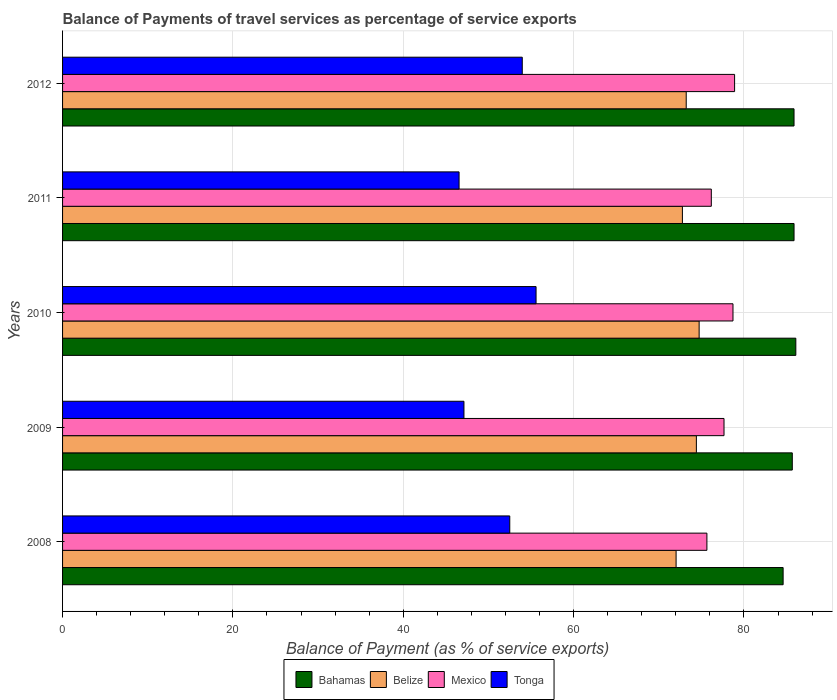Are the number of bars on each tick of the Y-axis equal?
Make the answer very short. Yes. How many bars are there on the 5th tick from the bottom?
Give a very brief answer. 4. In how many cases, is the number of bars for a given year not equal to the number of legend labels?
Provide a short and direct response. 0. What is the balance of payments of travel services in Tonga in 2012?
Keep it short and to the point. 53.97. Across all years, what is the maximum balance of payments of travel services in Tonga?
Provide a succinct answer. 55.59. Across all years, what is the minimum balance of payments of travel services in Tonga?
Keep it short and to the point. 46.55. In which year was the balance of payments of travel services in Bahamas minimum?
Offer a very short reply. 2008. What is the total balance of payments of travel services in Belize in the graph?
Offer a very short reply. 367.19. What is the difference between the balance of payments of travel services in Bahamas in 2008 and that in 2010?
Your answer should be compact. -1.49. What is the difference between the balance of payments of travel services in Bahamas in 2009 and the balance of payments of travel services in Mexico in 2012?
Make the answer very short. 6.77. What is the average balance of payments of travel services in Belize per year?
Give a very brief answer. 73.44. In the year 2010, what is the difference between the balance of payments of travel services in Tonga and balance of payments of travel services in Mexico?
Your answer should be very brief. -23.12. In how many years, is the balance of payments of travel services in Bahamas greater than 48 %?
Your answer should be compact. 5. What is the ratio of the balance of payments of travel services in Bahamas in 2010 to that in 2012?
Provide a short and direct response. 1. Is the difference between the balance of payments of travel services in Tonga in 2008 and 2012 greater than the difference between the balance of payments of travel services in Mexico in 2008 and 2012?
Ensure brevity in your answer.  Yes. What is the difference between the highest and the second highest balance of payments of travel services in Tonga?
Ensure brevity in your answer.  1.62. What is the difference between the highest and the lowest balance of payments of travel services in Bahamas?
Your answer should be compact. 1.49. In how many years, is the balance of payments of travel services in Belize greater than the average balance of payments of travel services in Belize taken over all years?
Offer a terse response. 2. What does the 4th bar from the top in 2010 represents?
Offer a very short reply. Bahamas. What does the 1st bar from the bottom in 2008 represents?
Keep it short and to the point. Bahamas. How many years are there in the graph?
Give a very brief answer. 5. What is the difference between two consecutive major ticks on the X-axis?
Your response must be concise. 20. Does the graph contain grids?
Provide a succinct answer. Yes. Where does the legend appear in the graph?
Your response must be concise. Bottom center. What is the title of the graph?
Provide a short and direct response. Balance of Payments of travel services as percentage of service exports. What is the label or title of the X-axis?
Your answer should be compact. Balance of Payment (as % of service exports). What is the Balance of Payment (as % of service exports) of Bahamas in 2008?
Provide a short and direct response. 84.6. What is the Balance of Payment (as % of service exports) of Belize in 2008?
Offer a terse response. 72.03. What is the Balance of Payment (as % of service exports) in Mexico in 2008?
Make the answer very short. 75.65. What is the Balance of Payment (as % of service exports) in Tonga in 2008?
Give a very brief answer. 52.51. What is the Balance of Payment (as % of service exports) in Bahamas in 2009?
Provide a short and direct response. 85.68. What is the Balance of Payment (as % of service exports) in Belize in 2009?
Make the answer very short. 74.42. What is the Balance of Payment (as % of service exports) in Mexico in 2009?
Give a very brief answer. 77.66. What is the Balance of Payment (as % of service exports) of Tonga in 2009?
Offer a very short reply. 47.13. What is the Balance of Payment (as % of service exports) in Bahamas in 2010?
Your answer should be very brief. 86.09. What is the Balance of Payment (as % of service exports) of Belize in 2010?
Offer a very short reply. 74.74. What is the Balance of Payment (as % of service exports) in Mexico in 2010?
Your answer should be very brief. 78.71. What is the Balance of Payment (as % of service exports) in Tonga in 2010?
Provide a succinct answer. 55.59. What is the Balance of Payment (as % of service exports) of Bahamas in 2011?
Make the answer very short. 85.88. What is the Balance of Payment (as % of service exports) of Belize in 2011?
Provide a succinct answer. 72.78. What is the Balance of Payment (as % of service exports) in Mexico in 2011?
Make the answer very short. 76.17. What is the Balance of Payment (as % of service exports) in Tonga in 2011?
Your answer should be very brief. 46.55. What is the Balance of Payment (as % of service exports) in Bahamas in 2012?
Provide a succinct answer. 85.88. What is the Balance of Payment (as % of service exports) of Belize in 2012?
Provide a succinct answer. 73.22. What is the Balance of Payment (as % of service exports) of Mexico in 2012?
Your answer should be compact. 78.9. What is the Balance of Payment (as % of service exports) of Tonga in 2012?
Your response must be concise. 53.97. Across all years, what is the maximum Balance of Payment (as % of service exports) of Bahamas?
Your answer should be very brief. 86.09. Across all years, what is the maximum Balance of Payment (as % of service exports) of Belize?
Your answer should be very brief. 74.74. Across all years, what is the maximum Balance of Payment (as % of service exports) in Mexico?
Offer a very short reply. 78.9. Across all years, what is the maximum Balance of Payment (as % of service exports) in Tonga?
Your answer should be compact. 55.59. Across all years, what is the minimum Balance of Payment (as % of service exports) in Bahamas?
Give a very brief answer. 84.6. Across all years, what is the minimum Balance of Payment (as % of service exports) in Belize?
Your answer should be very brief. 72.03. Across all years, what is the minimum Balance of Payment (as % of service exports) in Mexico?
Keep it short and to the point. 75.65. Across all years, what is the minimum Balance of Payment (as % of service exports) of Tonga?
Make the answer very short. 46.55. What is the total Balance of Payment (as % of service exports) in Bahamas in the graph?
Ensure brevity in your answer.  428.14. What is the total Balance of Payment (as % of service exports) in Belize in the graph?
Ensure brevity in your answer.  367.19. What is the total Balance of Payment (as % of service exports) in Mexico in the graph?
Your answer should be compact. 387.1. What is the total Balance of Payment (as % of service exports) in Tonga in the graph?
Provide a short and direct response. 255.76. What is the difference between the Balance of Payment (as % of service exports) of Bahamas in 2008 and that in 2009?
Keep it short and to the point. -1.08. What is the difference between the Balance of Payment (as % of service exports) of Belize in 2008 and that in 2009?
Make the answer very short. -2.38. What is the difference between the Balance of Payment (as % of service exports) in Mexico in 2008 and that in 2009?
Offer a terse response. -2.01. What is the difference between the Balance of Payment (as % of service exports) in Tonga in 2008 and that in 2009?
Provide a short and direct response. 5.38. What is the difference between the Balance of Payment (as % of service exports) of Bahamas in 2008 and that in 2010?
Ensure brevity in your answer.  -1.49. What is the difference between the Balance of Payment (as % of service exports) in Belize in 2008 and that in 2010?
Offer a very short reply. -2.71. What is the difference between the Balance of Payment (as % of service exports) in Mexico in 2008 and that in 2010?
Your answer should be compact. -3.06. What is the difference between the Balance of Payment (as % of service exports) of Tonga in 2008 and that in 2010?
Offer a terse response. -3.09. What is the difference between the Balance of Payment (as % of service exports) in Bahamas in 2008 and that in 2011?
Make the answer very short. -1.28. What is the difference between the Balance of Payment (as % of service exports) in Belize in 2008 and that in 2011?
Provide a short and direct response. -0.74. What is the difference between the Balance of Payment (as % of service exports) in Mexico in 2008 and that in 2011?
Give a very brief answer. -0.52. What is the difference between the Balance of Payment (as % of service exports) in Tonga in 2008 and that in 2011?
Your response must be concise. 5.95. What is the difference between the Balance of Payment (as % of service exports) in Bahamas in 2008 and that in 2012?
Ensure brevity in your answer.  -1.28. What is the difference between the Balance of Payment (as % of service exports) in Belize in 2008 and that in 2012?
Your answer should be compact. -1.19. What is the difference between the Balance of Payment (as % of service exports) of Mexico in 2008 and that in 2012?
Your answer should be very brief. -3.25. What is the difference between the Balance of Payment (as % of service exports) of Tonga in 2008 and that in 2012?
Give a very brief answer. -1.47. What is the difference between the Balance of Payment (as % of service exports) of Bahamas in 2009 and that in 2010?
Your answer should be very brief. -0.42. What is the difference between the Balance of Payment (as % of service exports) of Belize in 2009 and that in 2010?
Provide a succinct answer. -0.32. What is the difference between the Balance of Payment (as % of service exports) in Mexico in 2009 and that in 2010?
Make the answer very short. -1.05. What is the difference between the Balance of Payment (as % of service exports) in Tonga in 2009 and that in 2010?
Give a very brief answer. -8.47. What is the difference between the Balance of Payment (as % of service exports) of Bahamas in 2009 and that in 2011?
Ensure brevity in your answer.  -0.21. What is the difference between the Balance of Payment (as % of service exports) of Belize in 2009 and that in 2011?
Your answer should be very brief. 1.64. What is the difference between the Balance of Payment (as % of service exports) in Mexico in 2009 and that in 2011?
Provide a succinct answer. 1.49. What is the difference between the Balance of Payment (as % of service exports) in Tonga in 2009 and that in 2011?
Give a very brief answer. 0.57. What is the difference between the Balance of Payment (as % of service exports) in Bahamas in 2009 and that in 2012?
Your answer should be very brief. -0.2. What is the difference between the Balance of Payment (as % of service exports) of Belize in 2009 and that in 2012?
Give a very brief answer. 1.19. What is the difference between the Balance of Payment (as % of service exports) of Mexico in 2009 and that in 2012?
Provide a succinct answer. -1.24. What is the difference between the Balance of Payment (as % of service exports) of Tonga in 2009 and that in 2012?
Your answer should be compact. -6.85. What is the difference between the Balance of Payment (as % of service exports) of Bahamas in 2010 and that in 2011?
Your answer should be compact. 0.21. What is the difference between the Balance of Payment (as % of service exports) of Belize in 2010 and that in 2011?
Your answer should be very brief. 1.96. What is the difference between the Balance of Payment (as % of service exports) of Mexico in 2010 and that in 2011?
Give a very brief answer. 2.54. What is the difference between the Balance of Payment (as % of service exports) of Tonga in 2010 and that in 2011?
Offer a terse response. 9.04. What is the difference between the Balance of Payment (as % of service exports) of Bahamas in 2010 and that in 2012?
Your response must be concise. 0.21. What is the difference between the Balance of Payment (as % of service exports) in Belize in 2010 and that in 2012?
Give a very brief answer. 1.52. What is the difference between the Balance of Payment (as % of service exports) of Mexico in 2010 and that in 2012?
Keep it short and to the point. -0.19. What is the difference between the Balance of Payment (as % of service exports) in Tonga in 2010 and that in 2012?
Provide a succinct answer. 1.62. What is the difference between the Balance of Payment (as % of service exports) of Bahamas in 2011 and that in 2012?
Offer a terse response. 0. What is the difference between the Balance of Payment (as % of service exports) in Belize in 2011 and that in 2012?
Make the answer very short. -0.45. What is the difference between the Balance of Payment (as % of service exports) in Mexico in 2011 and that in 2012?
Provide a succinct answer. -2.73. What is the difference between the Balance of Payment (as % of service exports) in Tonga in 2011 and that in 2012?
Provide a succinct answer. -7.42. What is the difference between the Balance of Payment (as % of service exports) of Bahamas in 2008 and the Balance of Payment (as % of service exports) of Belize in 2009?
Ensure brevity in your answer.  10.19. What is the difference between the Balance of Payment (as % of service exports) of Bahamas in 2008 and the Balance of Payment (as % of service exports) of Mexico in 2009?
Offer a very short reply. 6.94. What is the difference between the Balance of Payment (as % of service exports) of Bahamas in 2008 and the Balance of Payment (as % of service exports) of Tonga in 2009?
Give a very brief answer. 37.48. What is the difference between the Balance of Payment (as % of service exports) in Belize in 2008 and the Balance of Payment (as % of service exports) in Mexico in 2009?
Offer a terse response. -5.63. What is the difference between the Balance of Payment (as % of service exports) of Belize in 2008 and the Balance of Payment (as % of service exports) of Tonga in 2009?
Provide a succinct answer. 24.91. What is the difference between the Balance of Payment (as % of service exports) in Mexico in 2008 and the Balance of Payment (as % of service exports) in Tonga in 2009?
Keep it short and to the point. 28.53. What is the difference between the Balance of Payment (as % of service exports) in Bahamas in 2008 and the Balance of Payment (as % of service exports) in Belize in 2010?
Ensure brevity in your answer.  9.86. What is the difference between the Balance of Payment (as % of service exports) in Bahamas in 2008 and the Balance of Payment (as % of service exports) in Mexico in 2010?
Provide a succinct answer. 5.89. What is the difference between the Balance of Payment (as % of service exports) of Bahamas in 2008 and the Balance of Payment (as % of service exports) of Tonga in 2010?
Provide a succinct answer. 29.01. What is the difference between the Balance of Payment (as % of service exports) in Belize in 2008 and the Balance of Payment (as % of service exports) in Mexico in 2010?
Ensure brevity in your answer.  -6.68. What is the difference between the Balance of Payment (as % of service exports) in Belize in 2008 and the Balance of Payment (as % of service exports) in Tonga in 2010?
Keep it short and to the point. 16.44. What is the difference between the Balance of Payment (as % of service exports) of Mexico in 2008 and the Balance of Payment (as % of service exports) of Tonga in 2010?
Ensure brevity in your answer.  20.06. What is the difference between the Balance of Payment (as % of service exports) of Bahamas in 2008 and the Balance of Payment (as % of service exports) of Belize in 2011?
Your answer should be compact. 11.83. What is the difference between the Balance of Payment (as % of service exports) in Bahamas in 2008 and the Balance of Payment (as % of service exports) in Mexico in 2011?
Make the answer very short. 8.43. What is the difference between the Balance of Payment (as % of service exports) in Bahamas in 2008 and the Balance of Payment (as % of service exports) in Tonga in 2011?
Offer a terse response. 38.05. What is the difference between the Balance of Payment (as % of service exports) in Belize in 2008 and the Balance of Payment (as % of service exports) in Mexico in 2011?
Provide a short and direct response. -4.14. What is the difference between the Balance of Payment (as % of service exports) of Belize in 2008 and the Balance of Payment (as % of service exports) of Tonga in 2011?
Offer a terse response. 25.48. What is the difference between the Balance of Payment (as % of service exports) in Mexico in 2008 and the Balance of Payment (as % of service exports) in Tonga in 2011?
Your response must be concise. 29.1. What is the difference between the Balance of Payment (as % of service exports) of Bahamas in 2008 and the Balance of Payment (as % of service exports) of Belize in 2012?
Offer a terse response. 11.38. What is the difference between the Balance of Payment (as % of service exports) in Bahamas in 2008 and the Balance of Payment (as % of service exports) in Mexico in 2012?
Your answer should be very brief. 5.7. What is the difference between the Balance of Payment (as % of service exports) of Bahamas in 2008 and the Balance of Payment (as % of service exports) of Tonga in 2012?
Offer a terse response. 30.63. What is the difference between the Balance of Payment (as % of service exports) of Belize in 2008 and the Balance of Payment (as % of service exports) of Mexico in 2012?
Provide a succinct answer. -6.87. What is the difference between the Balance of Payment (as % of service exports) of Belize in 2008 and the Balance of Payment (as % of service exports) of Tonga in 2012?
Provide a short and direct response. 18.06. What is the difference between the Balance of Payment (as % of service exports) of Mexico in 2008 and the Balance of Payment (as % of service exports) of Tonga in 2012?
Provide a short and direct response. 21.68. What is the difference between the Balance of Payment (as % of service exports) of Bahamas in 2009 and the Balance of Payment (as % of service exports) of Belize in 2010?
Your answer should be compact. 10.94. What is the difference between the Balance of Payment (as % of service exports) in Bahamas in 2009 and the Balance of Payment (as % of service exports) in Mexico in 2010?
Provide a succinct answer. 6.96. What is the difference between the Balance of Payment (as % of service exports) of Bahamas in 2009 and the Balance of Payment (as % of service exports) of Tonga in 2010?
Give a very brief answer. 30.09. What is the difference between the Balance of Payment (as % of service exports) in Belize in 2009 and the Balance of Payment (as % of service exports) in Mexico in 2010?
Keep it short and to the point. -4.3. What is the difference between the Balance of Payment (as % of service exports) of Belize in 2009 and the Balance of Payment (as % of service exports) of Tonga in 2010?
Keep it short and to the point. 18.82. What is the difference between the Balance of Payment (as % of service exports) of Mexico in 2009 and the Balance of Payment (as % of service exports) of Tonga in 2010?
Ensure brevity in your answer.  22.07. What is the difference between the Balance of Payment (as % of service exports) of Bahamas in 2009 and the Balance of Payment (as % of service exports) of Belize in 2011?
Offer a very short reply. 12.9. What is the difference between the Balance of Payment (as % of service exports) of Bahamas in 2009 and the Balance of Payment (as % of service exports) of Mexico in 2011?
Give a very brief answer. 9.51. What is the difference between the Balance of Payment (as % of service exports) of Bahamas in 2009 and the Balance of Payment (as % of service exports) of Tonga in 2011?
Give a very brief answer. 39.12. What is the difference between the Balance of Payment (as % of service exports) in Belize in 2009 and the Balance of Payment (as % of service exports) in Mexico in 2011?
Your answer should be very brief. -1.75. What is the difference between the Balance of Payment (as % of service exports) of Belize in 2009 and the Balance of Payment (as % of service exports) of Tonga in 2011?
Provide a short and direct response. 27.86. What is the difference between the Balance of Payment (as % of service exports) in Mexico in 2009 and the Balance of Payment (as % of service exports) in Tonga in 2011?
Keep it short and to the point. 31.11. What is the difference between the Balance of Payment (as % of service exports) in Bahamas in 2009 and the Balance of Payment (as % of service exports) in Belize in 2012?
Ensure brevity in your answer.  12.45. What is the difference between the Balance of Payment (as % of service exports) in Bahamas in 2009 and the Balance of Payment (as % of service exports) in Mexico in 2012?
Keep it short and to the point. 6.77. What is the difference between the Balance of Payment (as % of service exports) of Bahamas in 2009 and the Balance of Payment (as % of service exports) of Tonga in 2012?
Your response must be concise. 31.7. What is the difference between the Balance of Payment (as % of service exports) in Belize in 2009 and the Balance of Payment (as % of service exports) in Mexico in 2012?
Give a very brief answer. -4.49. What is the difference between the Balance of Payment (as % of service exports) of Belize in 2009 and the Balance of Payment (as % of service exports) of Tonga in 2012?
Ensure brevity in your answer.  20.44. What is the difference between the Balance of Payment (as % of service exports) of Mexico in 2009 and the Balance of Payment (as % of service exports) of Tonga in 2012?
Provide a succinct answer. 23.69. What is the difference between the Balance of Payment (as % of service exports) in Bahamas in 2010 and the Balance of Payment (as % of service exports) in Belize in 2011?
Offer a terse response. 13.32. What is the difference between the Balance of Payment (as % of service exports) in Bahamas in 2010 and the Balance of Payment (as % of service exports) in Mexico in 2011?
Offer a very short reply. 9.92. What is the difference between the Balance of Payment (as % of service exports) of Bahamas in 2010 and the Balance of Payment (as % of service exports) of Tonga in 2011?
Your answer should be very brief. 39.54. What is the difference between the Balance of Payment (as % of service exports) of Belize in 2010 and the Balance of Payment (as % of service exports) of Mexico in 2011?
Offer a very short reply. -1.43. What is the difference between the Balance of Payment (as % of service exports) in Belize in 2010 and the Balance of Payment (as % of service exports) in Tonga in 2011?
Offer a very short reply. 28.19. What is the difference between the Balance of Payment (as % of service exports) of Mexico in 2010 and the Balance of Payment (as % of service exports) of Tonga in 2011?
Give a very brief answer. 32.16. What is the difference between the Balance of Payment (as % of service exports) of Bahamas in 2010 and the Balance of Payment (as % of service exports) of Belize in 2012?
Your answer should be very brief. 12.87. What is the difference between the Balance of Payment (as % of service exports) in Bahamas in 2010 and the Balance of Payment (as % of service exports) in Mexico in 2012?
Offer a terse response. 7.19. What is the difference between the Balance of Payment (as % of service exports) in Bahamas in 2010 and the Balance of Payment (as % of service exports) in Tonga in 2012?
Your answer should be compact. 32.12. What is the difference between the Balance of Payment (as % of service exports) of Belize in 2010 and the Balance of Payment (as % of service exports) of Mexico in 2012?
Ensure brevity in your answer.  -4.16. What is the difference between the Balance of Payment (as % of service exports) in Belize in 2010 and the Balance of Payment (as % of service exports) in Tonga in 2012?
Ensure brevity in your answer.  20.77. What is the difference between the Balance of Payment (as % of service exports) in Mexico in 2010 and the Balance of Payment (as % of service exports) in Tonga in 2012?
Provide a short and direct response. 24.74. What is the difference between the Balance of Payment (as % of service exports) of Bahamas in 2011 and the Balance of Payment (as % of service exports) of Belize in 2012?
Offer a very short reply. 12.66. What is the difference between the Balance of Payment (as % of service exports) of Bahamas in 2011 and the Balance of Payment (as % of service exports) of Mexico in 2012?
Your response must be concise. 6.98. What is the difference between the Balance of Payment (as % of service exports) in Bahamas in 2011 and the Balance of Payment (as % of service exports) in Tonga in 2012?
Your answer should be very brief. 31.91. What is the difference between the Balance of Payment (as % of service exports) of Belize in 2011 and the Balance of Payment (as % of service exports) of Mexico in 2012?
Offer a terse response. -6.13. What is the difference between the Balance of Payment (as % of service exports) in Belize in 2011 and the Balance of Payment (as % of service exports) in Tonga in 2012?
Your answer should be very brief. 18.8. What is the difference between the Balance of Payment (as % of service exports) of Mexico in 2011 and the Balance of Payment (as % of service exports) of Tonga in 2012?
Offer a very short reply. 22.2. What is the average Balance of Payment (as % of service exports) of Bahamas per year?
Ensure brevity in your answer.  85.63. What is the average Balance of Payment (as % of service exports) of Belize per year?
Your answer should be compact. 73.44. What is the average Balance of Payment (as % of service exports) in Mexico per year?
Keep it short and to the point. 77.42. What is the average Balance of Payment (as % of service exports) in Tonga per year?
Keep it short and to the point. 51.15. In the year 2008, what is the difference between the Balance of Payment (as % of service exports) of Bahamas and Balance of Payment (as % of service exports) of Belize?
Provide a succinct answer. 12.57. In the year 2008, what is the difference between the Balance of Payment (as % of service exports) of Bahamas and Balance of Payment (as % of service exports) of Mexico?
Your answer should be very brief. 8.95. In the year 2008, what is the difference between the Balance of Payment (as % of service exports) of Bahamas and Balance of Payment (as % of service exports) of Tonga?
Your response must be concise. 32.1. In the year 2008, what is the difference between the Balance of Payment (as % of service exports) in Belize and Balance of Payment (as % of service exports) in Mexico?
Ensure brevity in your answer.  -3.62. In the year 2008, what is the difference between the Balance of Payment (as % of service exports) of Belize and Balance of Payment (as % of service exports) of Tonga?
Your answer should be compact. 19.53. In the year 2008, what is the difference between the Balance of Payment (as % of service exports) of Mexico and Balance of Payment (as % of service exports) of Tonga?
Provide a succinct answer. 23.14. In the year 2009, what is the difference between the Balance of Payment (as % of service exports) in Bahamas and Balance of Payment (as % of service exports) in Belize?
Give a very brief answer. 11.26. In the year 2009, what is the difference between the Balance of Payment (as % of service exports) in Bahamas and Balance of Payment (as % of service exports) in Mexico?
Offer a very short reply. 8.02. In the year 2009, what is the difference between the Balance of Payment (as % of service exports) of Bahamas and Balance of Payment (as % of service exports) of Tonga?
Provide a succinct answer. 38.55. In the year 2009, what is the difference between the Balance of Payment (as % of service exports) in Belize and Balance of Payment (as % of service exports) in Mexico?
Offer a terse response. -3.24. In the year 2009, what is the difference between the Balance of Payment (as % of service exports) in Belize and Balance of Payment (as % of service exports) in Tonga?
Offer a terse response. 27.29. In the year 2009, what is the difference between the Balance of Payment (as % of service exports) in Mexico and Balance of Payment (as % of service exports) in Tonga?
Your answer should be compact. 30.53. In the year 2010, what is the difference between the Balance of Payment (as % of service exports) of Bahamas and Balance of Payment (as % of service exports) of Belize?
Provide a succinct answer. 11.35. In the year 2010, what is the difference between the Balance of Payment (as % of service exports) in Bahamas and Balance of Payment (as % of service exports) in Mexico?
Give a very brief answer. 7.38. In the year 2010, what is the difference between the Balance of Payment (as % of service exports) in Bahamas and Balance of Payment (as % of service exports) in Tonga?
Offer a very short reply. 30.5. In the year 2010, what is the difference between the Balance of Payment (as % of service exports) of Belize and Balance of Payment (as % of service exports) of Mexico?
Your response must be concise. -3.97. In the year 2010, what is the difference between the Balance of Payment (as % of service exports) in Belize and Balance of Payment (as % of service exports) in Tonga?
Provide a short and direct response. 19.15. In the year 2010, what is the difference between the Balance of Payment (as % of service exports) of Mexico and Balance of Payment (as % of service exports) of Tonga?
Give a very brief answer. 23.12. In the year 2011, what is the difference between the Balance of Payment (as % of service exports) of Bahamas and Balance of Payment (as % of service exports) of Belize?
Provide a short and direct response. 13.11. In the year 2011, what is the difference between the Balance of Payment (as % of service exports) of Bahamas and Balance of Payment (as % of service exports) of Mexico?
Make the answer very short. 9.71. In the year 2011, what is the difference between the Balance of Payment (as % of service exports) in Bahamas and Balance of Payment (as % of service exports) in Tonga?
Offer a very short reply. 39.33. In the year 2011, what is the difference between the Balance of Payment (as % of service exports) of Belize and Balance of Payment (as % of service exports) of Mexico?
Your response must be concise. -3.39. In the year 2011, what is the difference between the Balance of Payment (as % of service exports) in Belize and Balance of Payment (as % of service exports) in Tonga?
Your answer should be compact. 26.22. In the year 2011, what is the difference between the Balance of Payment (as % of service exports) in Mexico and Balance of Payment (as % of service exports) in Tonga?
Your answer should be compact. 29.62. In the year 2012, what is the difference between the Balance of Payment (as % of service exports) in Bahamas and Balance of Payment (as % of service exports) in Belize?
Your response must be concise. 12.66. In the year 2012, what is the difference between the Balance of Payment (as % of service exports) in Bahamas and Balance of Payment (as % of service exports) in Mexico?
Offer a very short reply. 6.98. In the year 2012, what is the difference between the Balance of Payment (as % of service exports) of Bahamas and Balance of Payment (as % of service exports) of Tonga?
Provide a succinct answer. 31.91. In the year 2012, what is the difference between the Balance of Payment (as % of service exports) in Belize and Balance of Payment (as % of service exports) in Mexico?
Keep it short and to the point. -5.68. In the year 2012, what is the difference between the Balance of Payment (as % of service exports) of Belize and Balance of Payment (as % of service exports) of Tonga?
Keep it short and to the point. 19.25. In the year 2012, what is the difference between the Balance of Payment (as % of service exports) of Mexico and Balance of Payment (as % of service exports) of Tonga?
Your answer should be compact. 24.93. What is the ratio of the Balance of Payment (as % of service exports) of Bahamas in 2008 to that in 2009?
Give a very brief answer. 0.99. What is the ratio of the Balance of Payment (as % of service exports) in Mexico in 2008 to that in 2009?
Offer a terse response. 0.97. What is the ratio of the Balance of Payment (as % of service exports) in Tonga in 2008 to that in 2009?
Offer a very short reply. 1.11. What is the ratio of the Balance of Payment (as % of service exports) in Bahamas in 2008 to that in 2010?
Offer a terse response. 0.98. What is the ratio of the Balance of Payment (as % of service exports) of Belize in 2008 to that in 2010?
Your answer should be compact. 0.96. What is the ratio of the Balance of Payment (as % of service exports) of Mexico in 2008 to that in 2010?
Give a very brief answer. 0.96. What is the ratio of the Balance of Payment (as % of service exports) of Tonga in 2008 to that in 2010?
Your response must be concise. 0.94. What is the ratio of the Balance of Payment (as % of service exports) in Bahamas in 2008 to that in 2011?
Provide a succinct answer. 0.99. What is the ratio of the Balance of Payment (as % of service exports) of Tonga in 2008 to that in 2011?
Provide a succinct answer. 1.13. What is the ratio of the Balance of Payment (as % of service exports) in Bahamas in 2008 to that in 2012?
Your answer should be compact. 0.99. What is the ratio of the Balance of Payment (as % of service exports) of Belize in 2008 to that in 2012?
Make the answer very short. 0.98. What is the ratio of the Balance of Payment (as % of service exports) of Mexico in 2008 to that in 2012?
Your response must be concise. 0.96. What is the ratio of the Balance of Payment (as % of service exports) of Tonga in 2008 to that in 2012?
Your answer should be very brief. 0.97. What is the ratio of the Balance of Payment (as % of service exports) in Mexico in 2009 to that in 2010?
Keep it short and to the point. 0.99. What is the ratio of the Balance of Payment (as % of service exports) in Tonga in 2009 to that in 2010?
Your response must be concise. 0.85. What is the ratio of the Balance of Payment (as % of service exports) of Bahamas in 2009 to that in 2011?
Make the answer very short. 1. What is the ratio of the Balance of Payment (as % of service exports) in Belize in 2009 to that in 2011?
Keep it short and to the point. 1.02. What is the ratio of the Balance of Payment (as % of service exports) of Mexico in 2009 to that in 2011?
Make the answer very short. 1.02. What is the ratio of the Balance of Payment (as % of service exports) in Tonga in 2009 to that in 2011?
Provide a succinct answer. 1.01. What is the ratio of the Balance of Payment (as % of service exports) of Bahamas in 2009 to that in 2012?
Your answer should be compact. 1. What is the ratio of the Balance of Payment (as % of service exports) of Belize in 2009 to that in 2012?
Provide a succinct answer. 1.02. What is the ratio of the Balance of Payment (as % of service exports) in Mexico in 2009 to that in 2012?
Keep it short and to the point. 0.98. What is the ratio of the Balance of Payment (as % of service exports) in Tonga in 2009 to that in 2012?
Keep it short and to the point. 0.87. What is the ratio of the Balance of Payment (as % of service exports) of Bahamas in 2010 to that in 2011?
Your response must be concise. 1. What is the ratio of the Balance of Payment (as % of service exports) of Belize in 2010 to that in 2011?
Keep it short and to the point. 1.03. What is the ratio of the Balance of Payment (as % of service exports) of Mexico in 2010 to that in 2011?
Offer a very short reply. 1.03. What is the ratio of the Balance of Payment (as % of service exports) of Tonga in 2010 to that in 2011?
Provide a succinct answer. 1.19. What is the ratio of the Balance of Payment (as % of service exports) in Belize in 2010 to that in 2012?
Provide a succinct answer. 1.02. What is the ratio of the Balance of Payment (as % of service exports) of Tonga in 2010 to that in 2012?
Ensure brevity in your answer.  1.03. What is the ratio of the Balance of Payment (as % of service exports) in Bahamas in 2011 to that in 2012?
Keep it short and to the point. 1. What is the ratio of the Balance of Payment (as % of service exports) of Mexico in 2011 to that in 2012?
Offer a terse response. 0.97. What is the ratio of the Balance of Payment (as % of service exports) of Tonga in 2011 to that in 2012?
Make the answer very short. 0.86. What is the difference between the highest and the second highest Balance of Payment (as % of service exports) of Bahamas?
Offer a very short reply. 0.21. What is the difference between the highest and the second highest Balance of Payment (as % of service exports) of Belize?
Make the answer very short. 0.32. What is the difference between the highest and the second highest Balance of Payment (as % of service exports) of Mexico?
Offer a terse response. 0.19. What is the difference between the highest and the second highest Balance of Payment (as % of service exports) in Tonga?
Provide a succinct answer. 1.62. What is the difference between the highest and the lowest Balance of Payment (as % of service exports) of Bahamas?
Make the answer very short. 1.49. What is the difference between the highest and the lowest Balance of Payment (as % of service exports) in Belize?
Your answer should be compact. 2.71. What is the difference between the highest and the lowest Balance of Payment (as % of service exports) in Mexico?
Provide a short and direct response. 3.25. What is the difference between the highest and the lowest Balance of Payment (as % of service exports) of Tonga?
Provide a succinct answer. 9.04. 